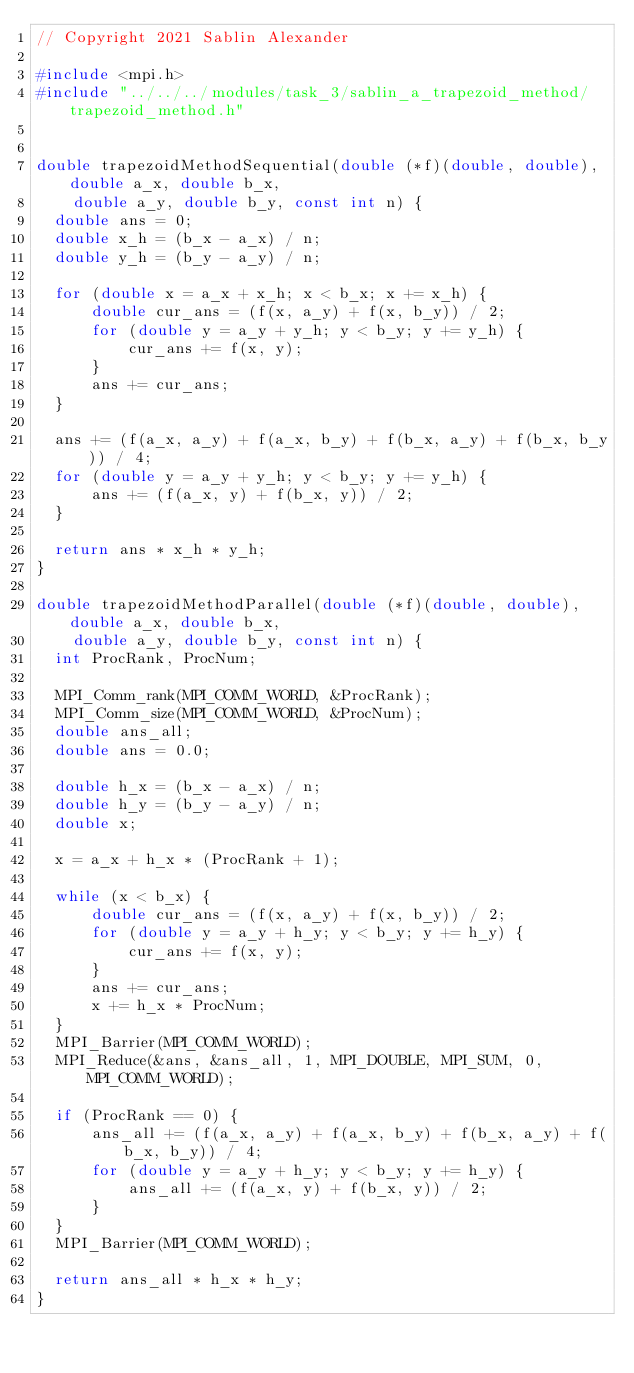<code> <loc_0><loc_0><loc_500><loc_500><_C++_>// Copyright 2021 Sablin Alexander

#include <mpi.h>
#include "../../../modules/task_3/sablin_a_trapezoid_method/trapezoid_method.h"


double trapezoidMethodSequential(double (*f)(double, double), double a_x, double b_x,
    double a_y, double b_y, const int n) {
  double ans = 0;
  double x_h = (b_x - a_x) / n;
  double y_h = (b_y - a_y) / n;

  for (double x = a_x + x_h; x < b_x; x += x_h) {
      double cur_ans = (f(x, a_y) + f(x, b_y)) / 2;
      for (double y = a_y + y_h; y < b_y; y += y_h) {
          cur_ans += f(x, y);
      }
      ans += cur_ans;
  }

  ans += (f(a_x, a_y) + f(a_x, b_y) + f(b_x, a_y) + f(b_x, b_y)) / 4;
  for (double y = a_y + y_h; y < b_y; y += y_h) {
      ans += (f(a_x, y) + f(b_x, y)) / 2;
  }

  return ans * x_h * y_h;
}

double trapezoidMethodParallel(double (*f)(double, double), double a_x, double b_x,
    double a_y, double b_y, const int n) {
  int ProcRank, ProcNum;

  MPI_Comm_rank(MPI_COMM_WORLD, &ProcRank);
  MPI_Comm_size(MPI_COMM_WORLD, &ProcNum);
  double ans_all;
  double ans = 0.0;

  double h_x = (b_x - a_x) / n;
  double h_y = (b_y - a_y) / n;
  double x;

  x = a_x + h_x * (ProcRank + 1);

  while (x < b_x) {
      double cur_ans = (f(x, a_y) + f(x, b_y)) / 2;
      for (double y = a_y + h_y; y < b_y; y += h_y) {
          cur_ans += f(x, y);
      }
      ans += cur_ans;
      x += h_x * ProcNum;
  }
  MPI_Barrier(MPI_COMM_WORLD);
  MPI_Reduce(&ans, &ans_all, 1, MPI_DOUBLE, MPI_SUM, 0, MPI_COMM_WORLD);

  if (ProcRank == 0) {
      ans_all += (f(a_x, a_y) + f(a_x, b_y) + f(b_x, a_y) + f(b_x, b_y)) / 4;
      for (double y = a_y + h_y; y < b_y; y += h_y) {
          ans_all += (f(a_x, y) + f(b_x, y)) / 2;
      }
  }
  MPI_Barrier(MPI_COMM_WORLD);

  return ans_all * h_x * h_y;
}
</code> 